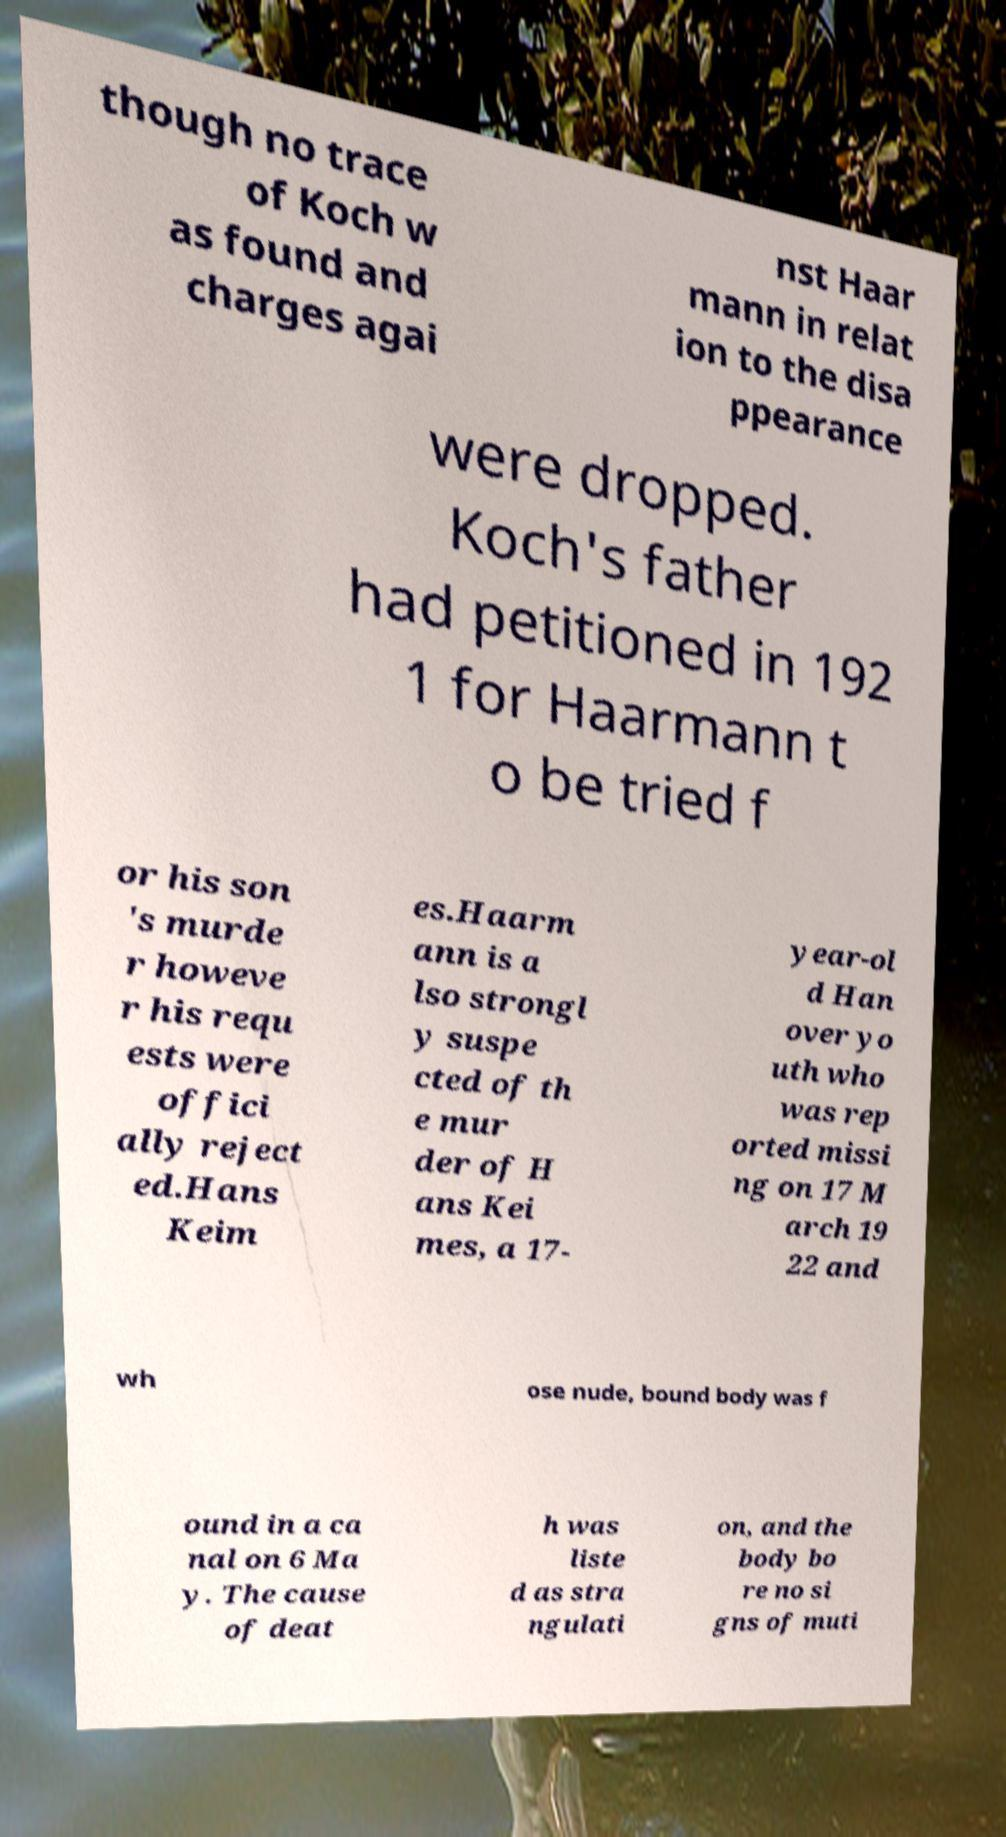Please identify and transcribe the text found in this image. though no trace of Koch w as found and charges agai nst Haar mann in relat ion to the disa ppearance were dropped. Koch's father had petitioned in 192 1 for Haarmann t o be tried f or his son 's murde r howeve r his requ ests were offici ally reject ed.Hans Keim es.Haarm ann is a lso strongl y suspe cted of th e mur der of H ans Kei mes, a 17- year-ol d Han over yo uth who was rep orted missi ng on 17 M arch 19 22 and wh ose nude, bound body was f ound in a ca nal on 6 Ma y. The cause of deat h was liste d as stra ngulati on, and the body bo re no si gns of muti 